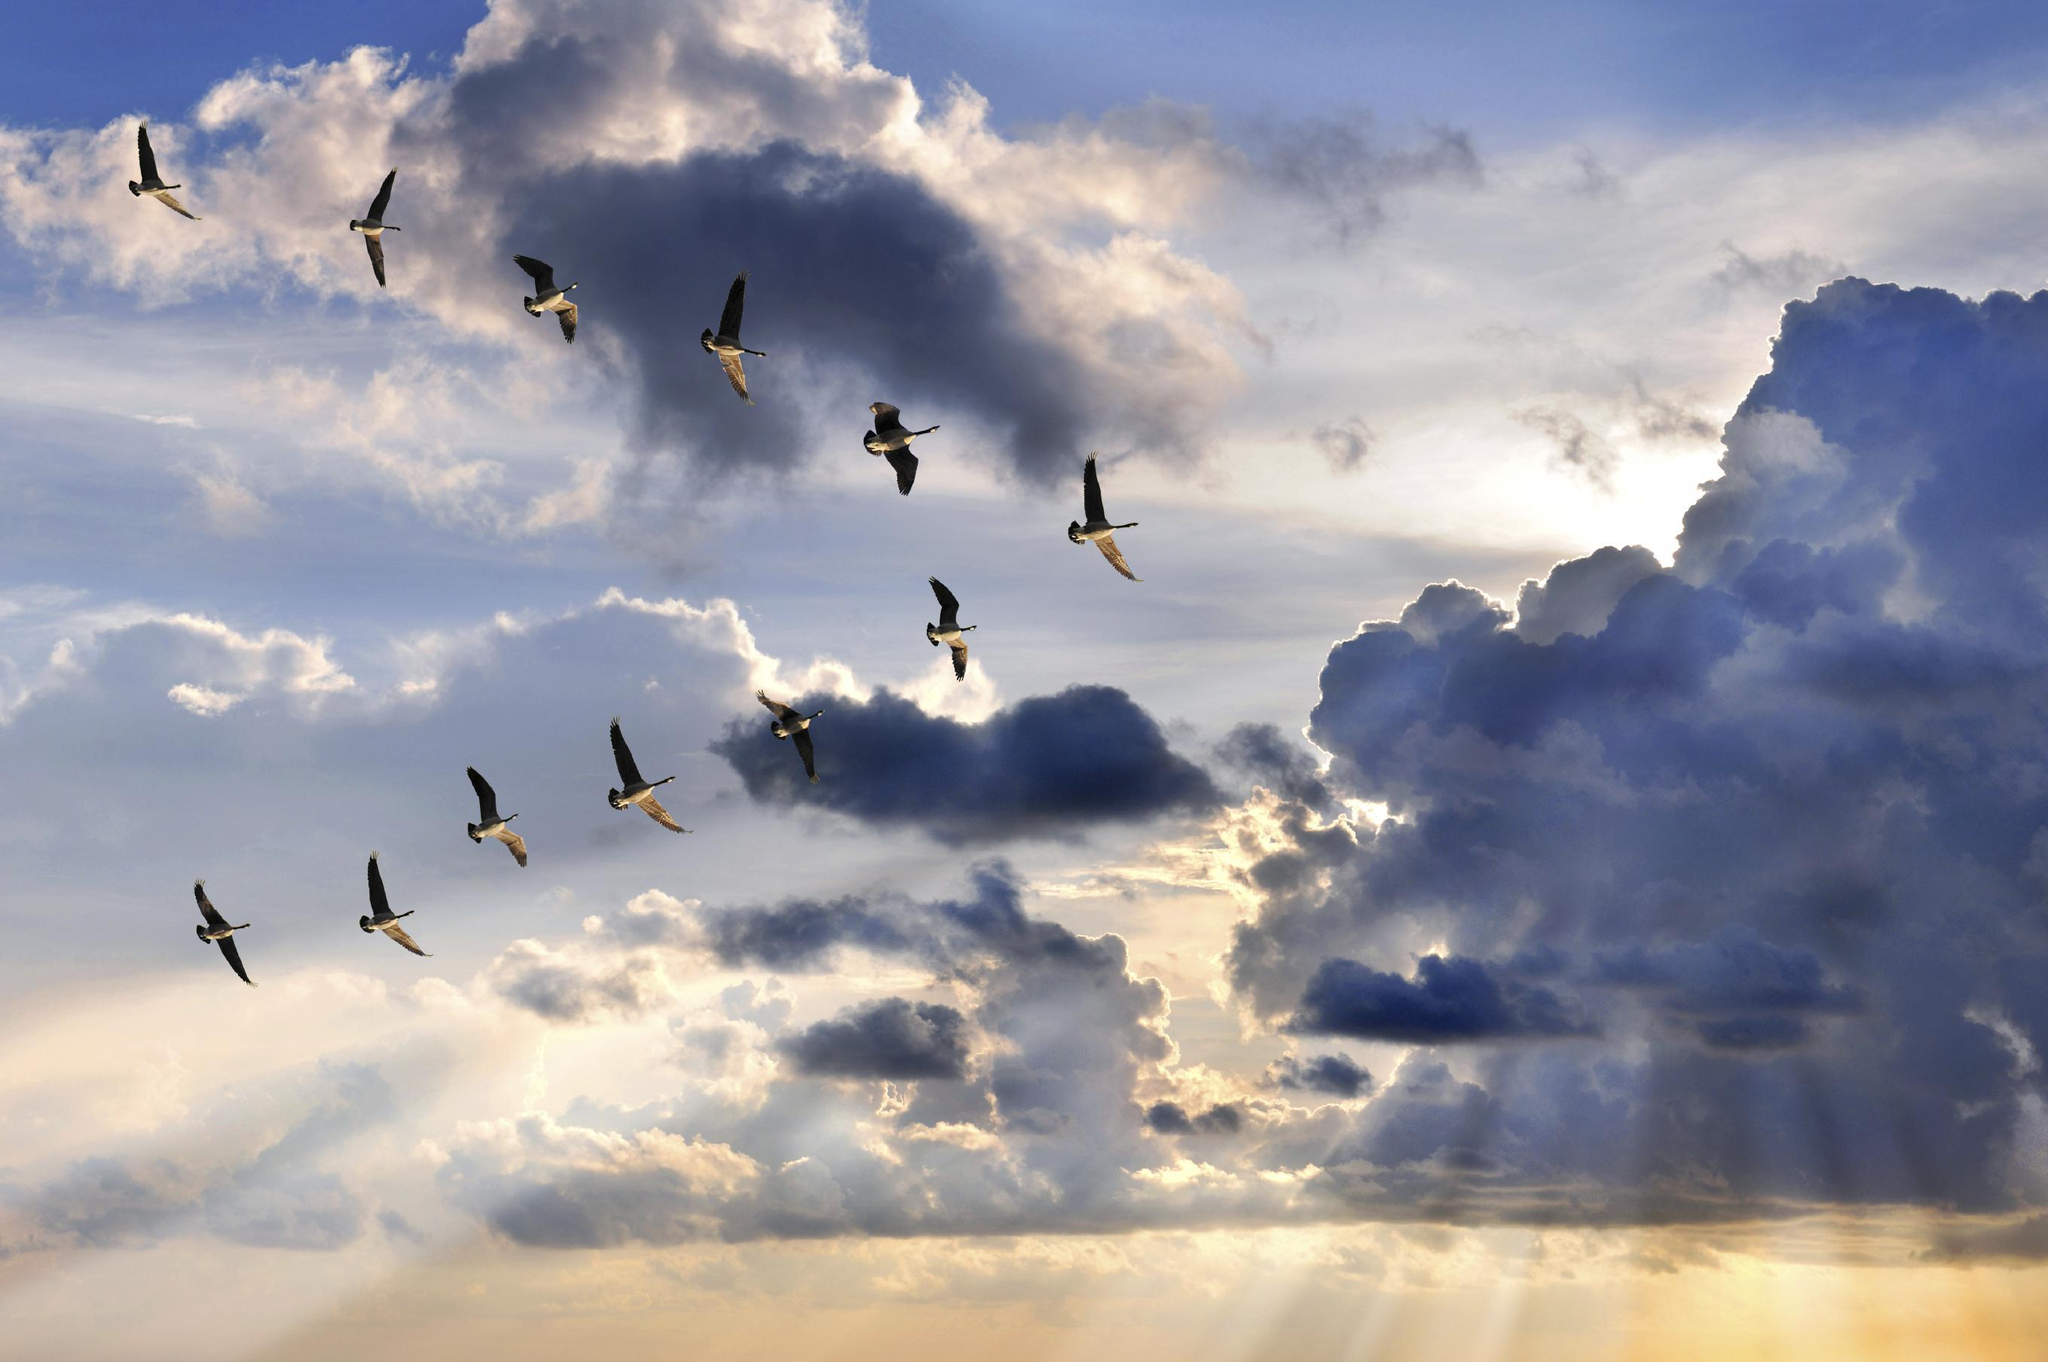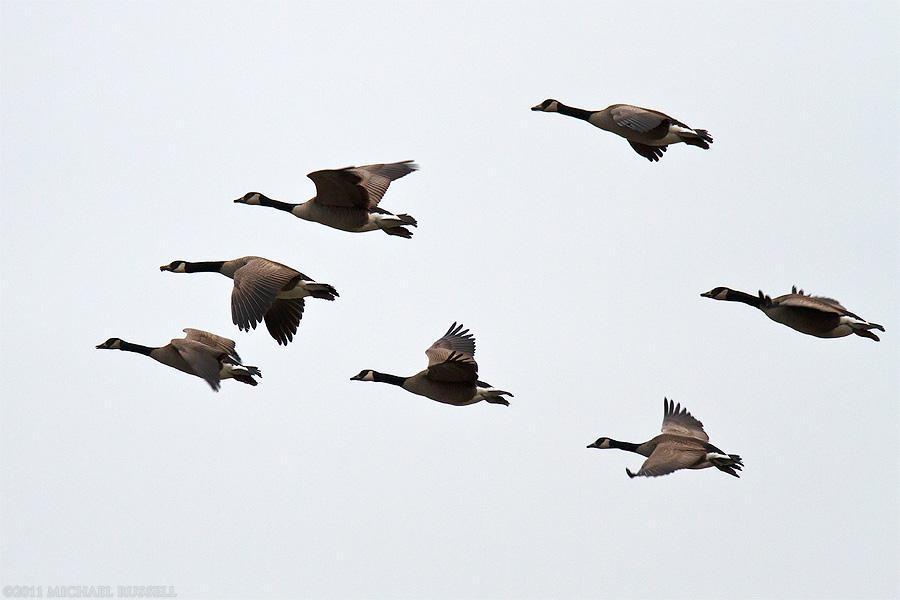The first image is the image on the left, the second image is the image on the right. For the images shown, is this caption "The right image shows geese flying rightward in a V formation on a clear turquoise-blue sky." true? Answer yes or no. No. The first image is the image on the left, the second image is the image on the right. Considering the images on both sides, is "there are 6 geese in flight" valid? Answer yes or no. No. 